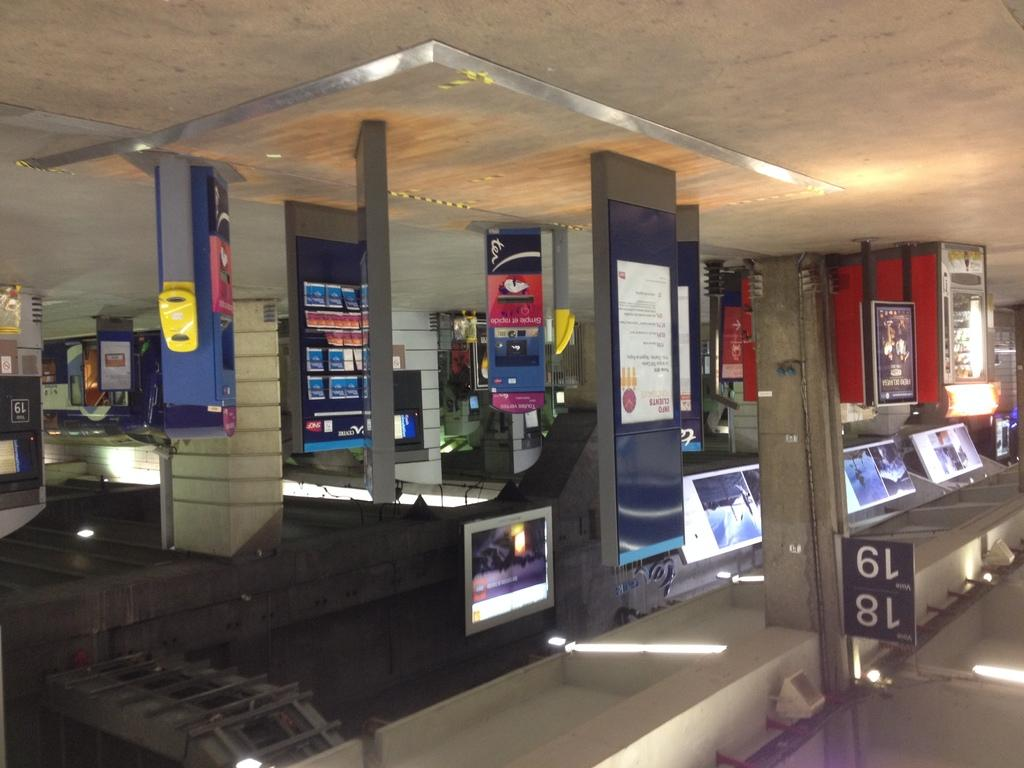<image>
Present a compact description of the photo's key features. An upside down depiction of area 18 and 19 in an electronics store. 